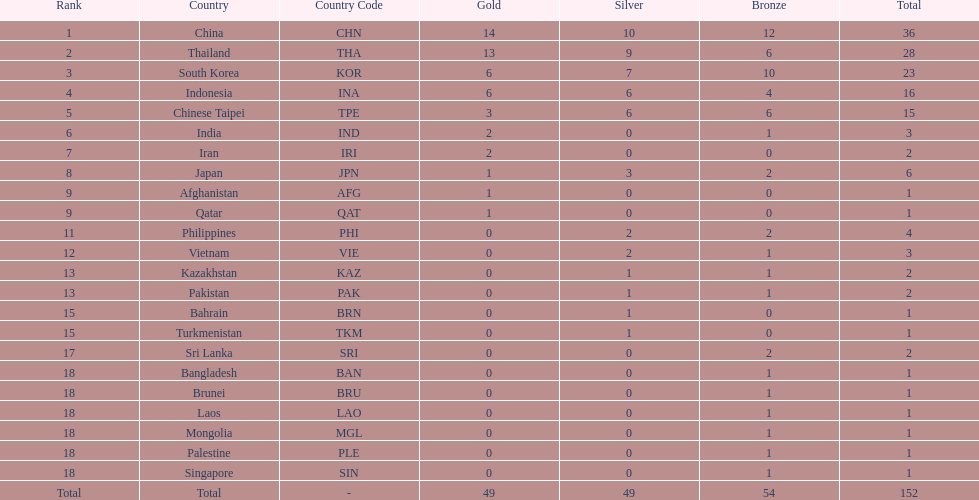How many combined silver medals did china, india, and japan earn ? 13. 